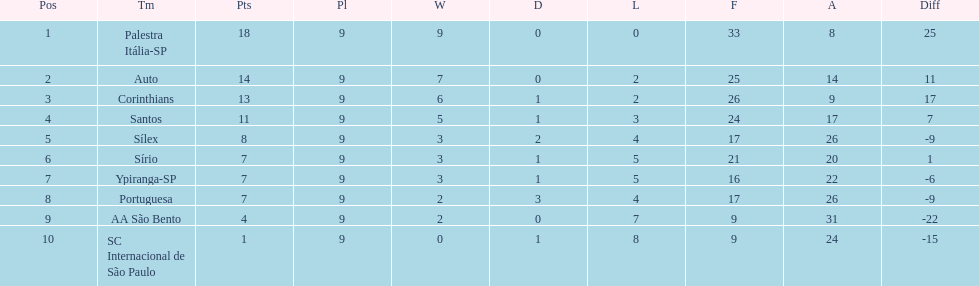Which brazilian team took the top spot in the 1926 brazilian football cup? Palestra Itália-SP. 